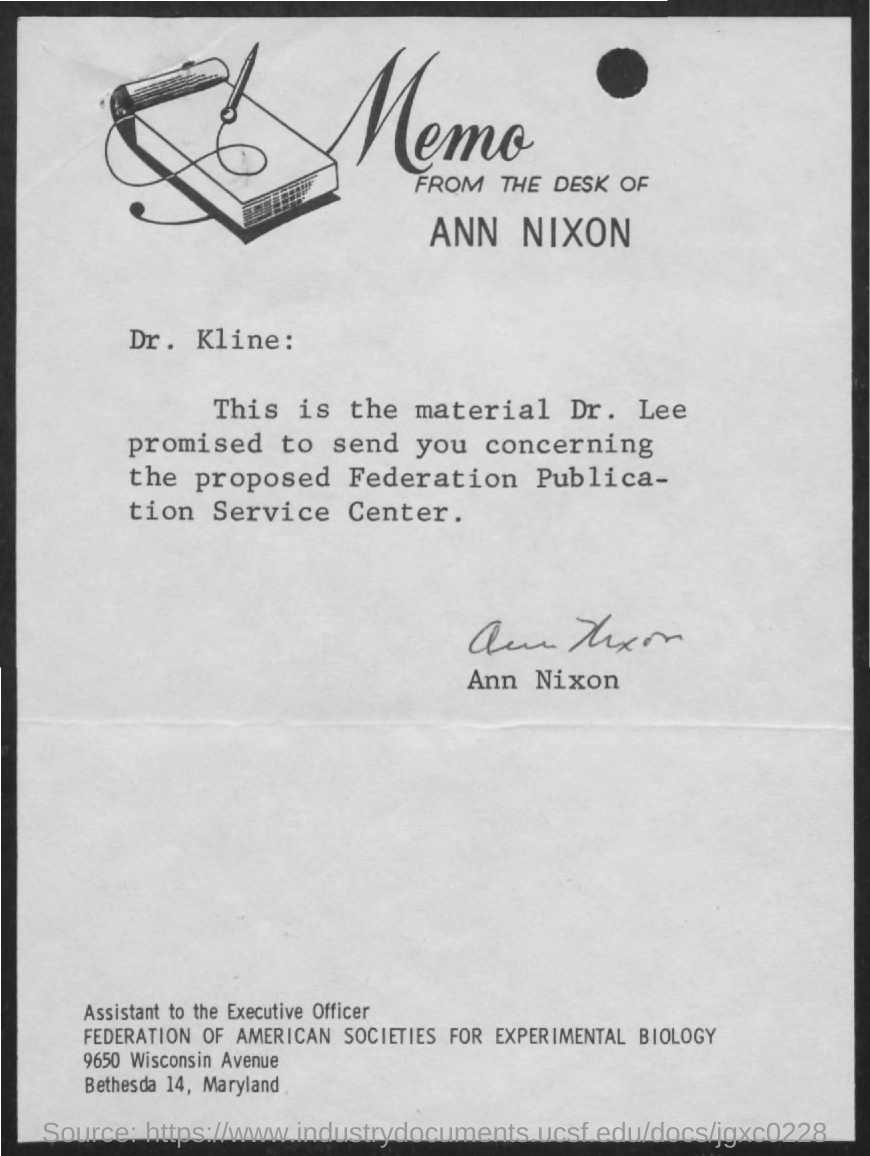Who is the sender of the memo?
Offer a very short reply. Ann Nixon. To whom, the memo is addressed?
Offer a terse response. DR. KLINE. What is the designation of Ann Nixon?
Ensure brevity in your answer.  Assistant to the Executive Officer. 